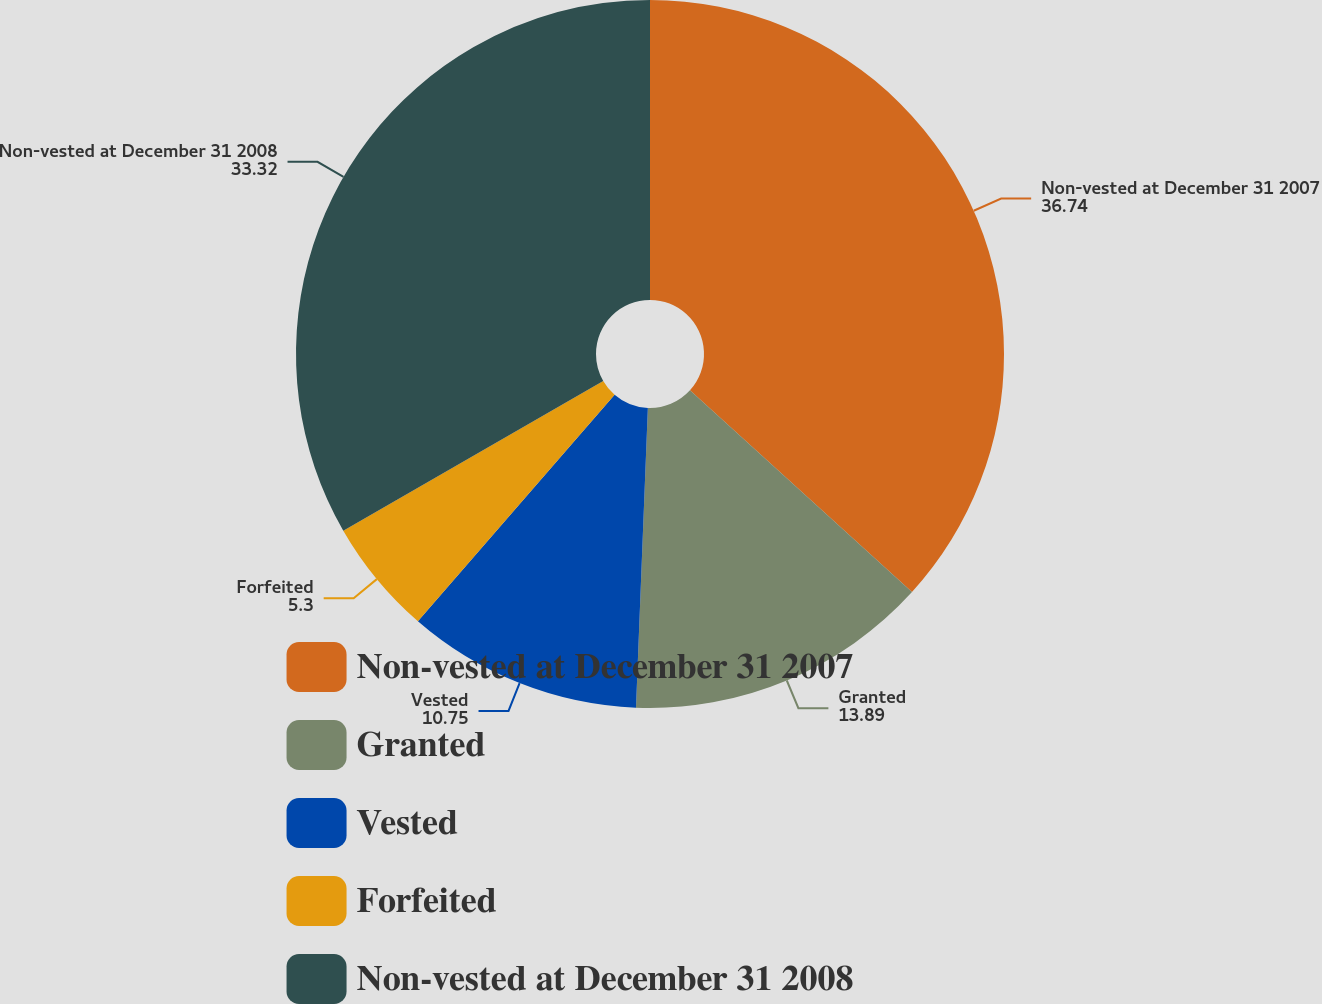Convert chart. <chart><loc_0><loc_0><loc_500><loc_500><pie_chart><fcel>Non-vested at December 31 2007<fcel>Granted<fcel>Vested<fcel>Forfeited<fcel>Non-vested at December 31 2008<nl><fcel>36.74%<fcel>13.89%<fcel>10.75%<fcel>5.3%<fcel>33.32%<nl></chart> 